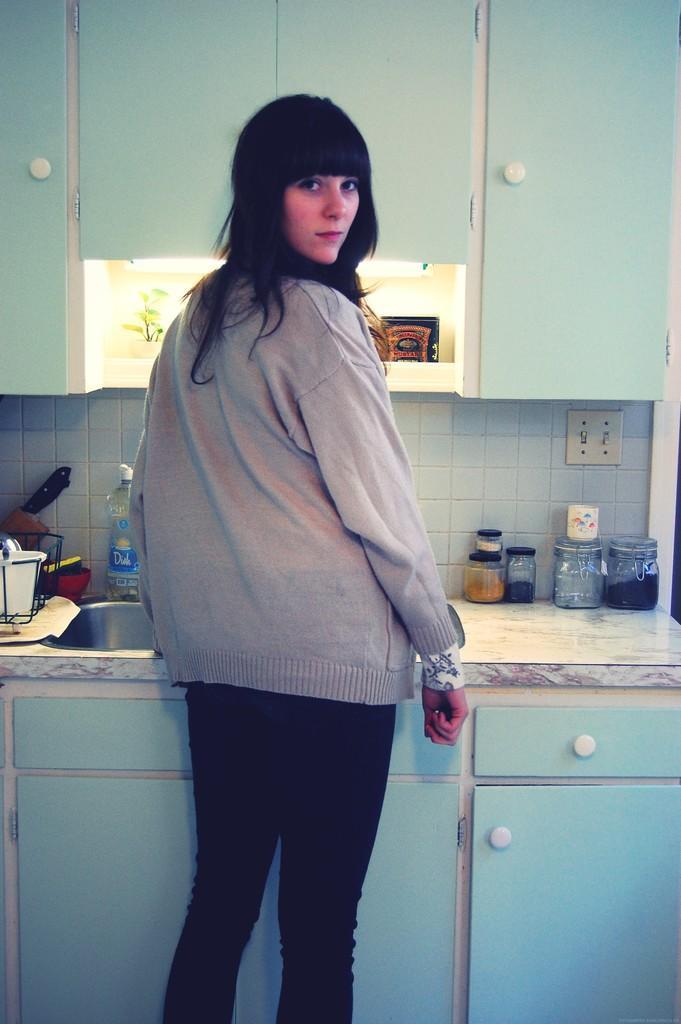Please provide a concise description of this image. In the image we can see a woman standing, wearing clothes. There is a wash basin, water bottle, knife, jar bottles, cupboards and a plant. 